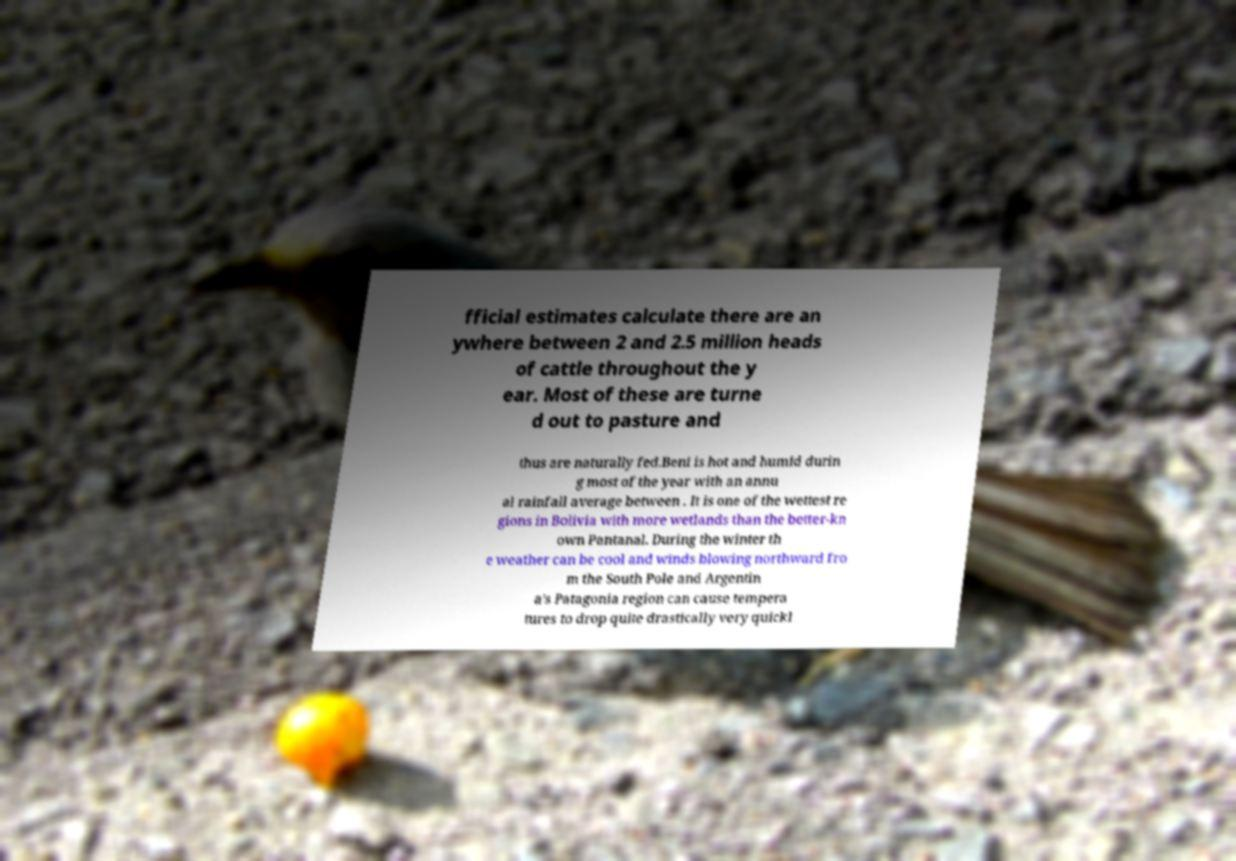What messages or text are displayed in this image? I need them in a readable, typed format. fficial estimates calculate there are an ywhere between 2 and 2.5 million heads of cattle throughout the y ear. Most of these are turne d out to pasture and thus are naturally fed.Beni is hot and humid durin g most of the year with an annu al rainfall average between . It is one of the wettest re gions in Bolivia with more wetlands than the better-kn own Pantanal. During the winter th e weather can be cool and winds blowing northward fro m the South Pole and Argentin a's Patagonia region can cause tempera tures to drop quite drastically very quickl 